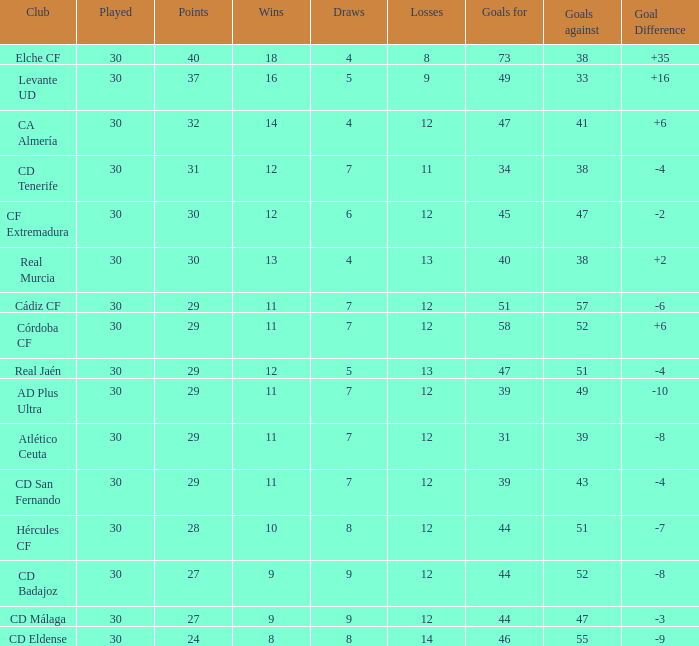What is the total number of losses with less than 73 goals for, less than 11 wins, more than 24 points, and a position greater than 15? 0.0. 